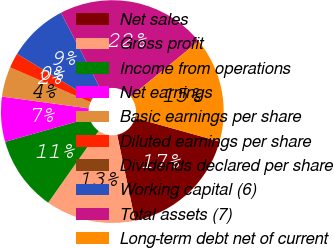Convert chart. <chart><loc_0><loc_0><loc_500><loc_500><pie_chart><fcel>Net sales<fcel>Gross profit<fcel>Income from operations<fcel>Net earnings<fcel>Basic earnings per share<fcel>Diluted earnings per share<fcel>Dividends declared per share<fcel>Working capital (6)<fcel>Total assets (7)<fcel>Long-term debt net of current<nl><fcel>17.39%<fcel>13.04%<fcel>10.87%<fcel>6.52%<fcel>4.35%<fcel>2.17%<fcel>0.0%<fcel>8.7%<fcel>21.74%<fcel>15.22%<nl></chart> 